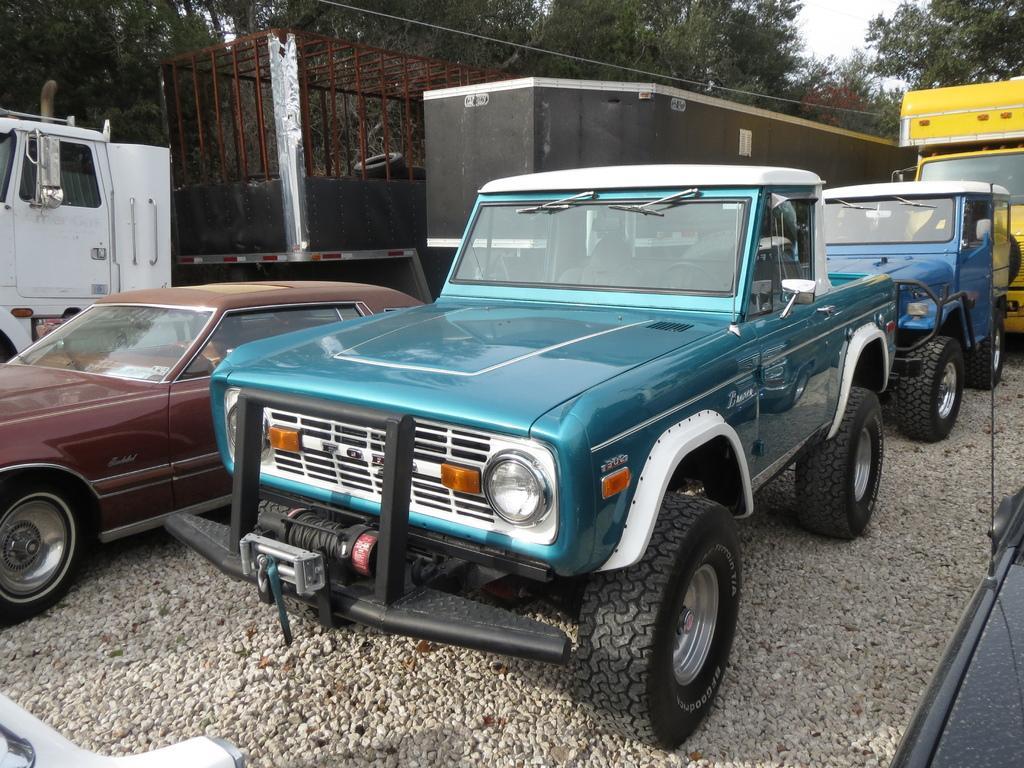Could you give a brief overview of what you see in this image? In this image, there are some vehicles in different colors. There is a cage on the truck. There are some trees at the top of the image. 